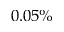<formula> <loc_0><loc_0><loc_500><loc_500>0 . 0 5 \%</formula> 